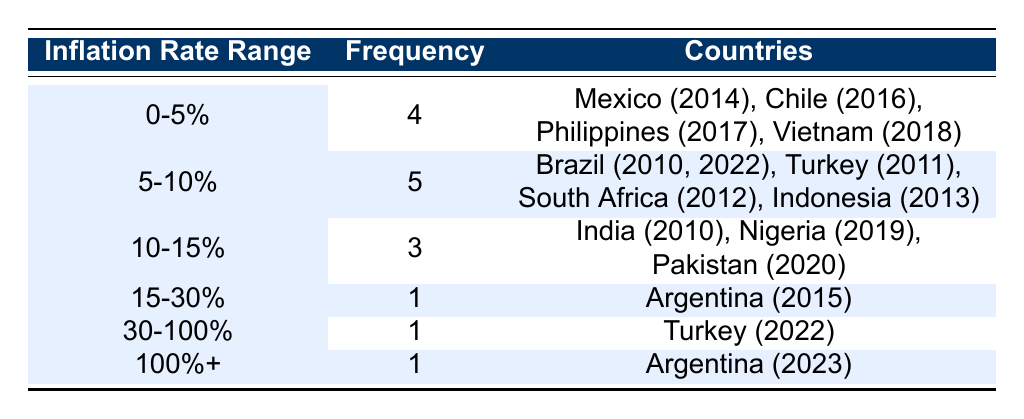What is the frequency of countries experiencing inflation rates between 0 and 5%? The table shows that there are 4 countries with inflation rates in the range of 0-5%: Mexico (2014), Chile (2016), Philippines (2017), and Vietnam (2018).
Answer: 4 Which country had the highest inflation rate in the table? Looking at the table, Argentina in 2023 has the highest recorded inflation rate at 104.3%, which exceeds all other countries' rates listed.
Answer: Argentina (2023) How many countries experienced inflation rates above 15%? The table indicates that there are 2 categories where inflation rates exceed 15%, specifically the 15-30% (1 country) and the 100%+ (1 country). Thus, the total is 1 + 1 = 2 countries.
Answer: 2 Can we say that the majority of countries had an inflation rate of less than 10%? Reviewing the table, there are a total of 9 entries, and 5 of them (in the 0-5% and 5-10% ranges) had rates under 10%. Since this is more than half, the statement is true.
Answer: Yes What is the average inflation rate for countries in the 5-10% range? The countries in the 5-10% range are Brazil (2010, 2022), Turkey (2011), South Africa (2012), and Indonesia (2013). Summing their rates gives 5.9 + 7.5 + 6.5 + 5.6 + 8.4 = 33.0. Dividing by the 5 countries, we find the average is 33.0 / 5 = 6.6%.
Answer: 6.6% 